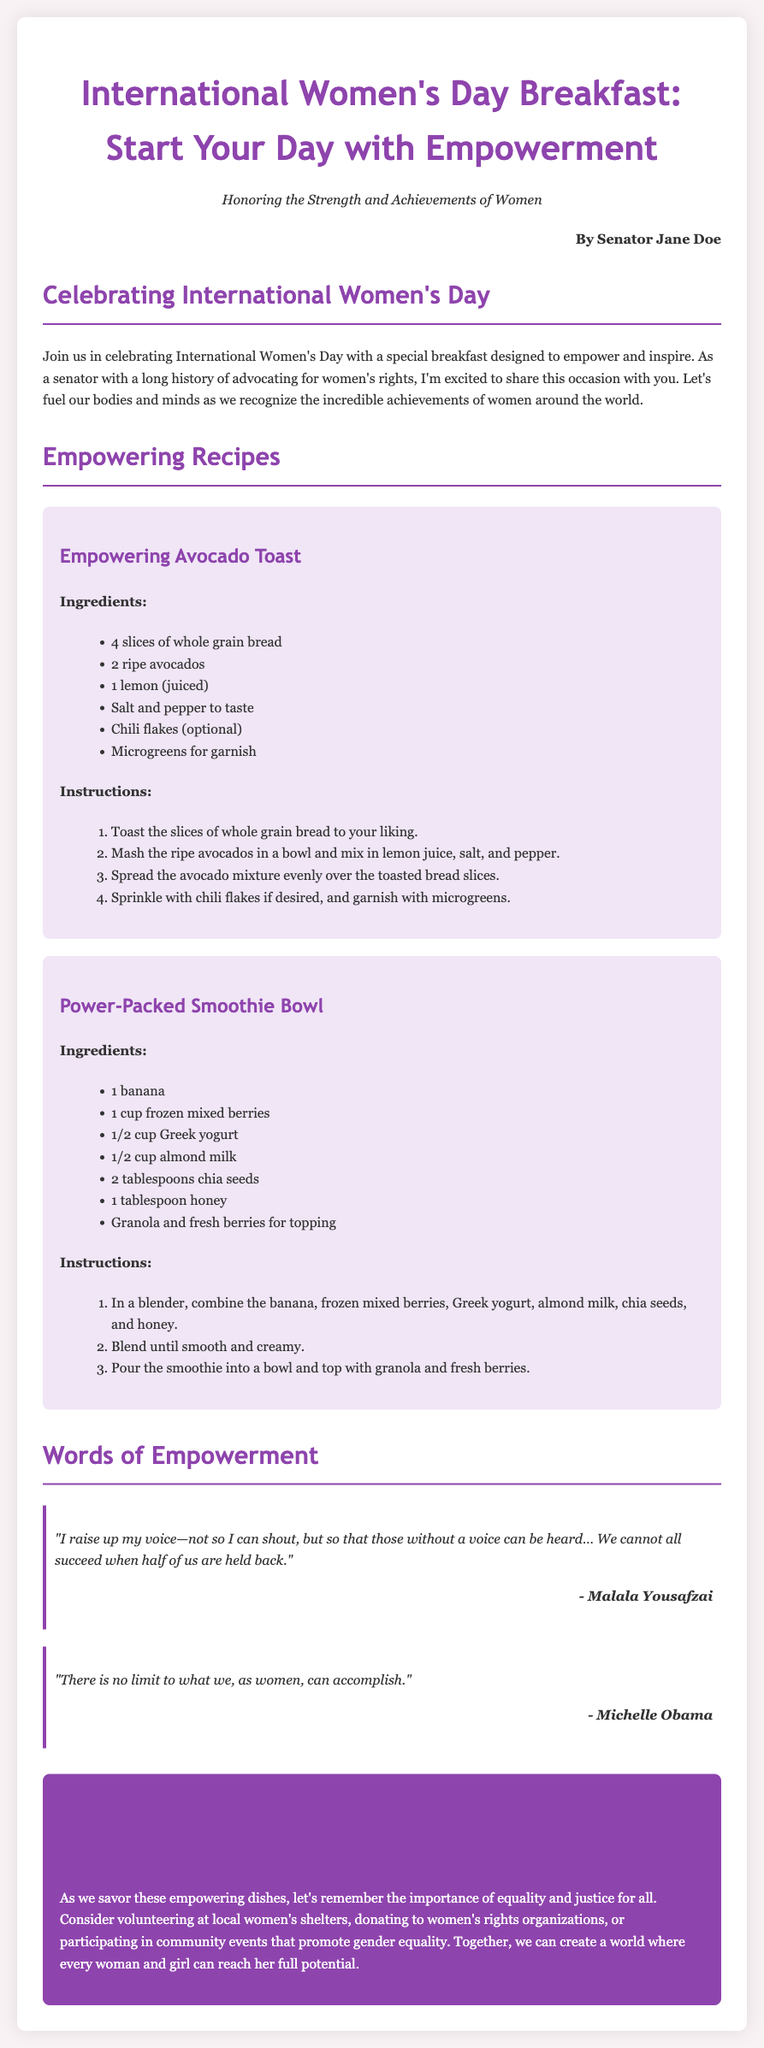What is the title of the document? The title is prominently displayed at the top of the document.
Answer: International Women's Day Breakfast: Start Your Day with Empowerment Who is the author of the document? The author is indicated in the byline below the subtitle.
Answer: Senator Jane Doe What are the main ingredients for the Empowering Avocado Toast? This information can be found in the ingredient list for the recipe.
Answer: 4 slices of whole grain bread, 2 ripe avocados, 1 lemon, salt and pepper to taste How many ingredients are listed for the Power-Packed Smoothie Bowl? The number of items can be counted from the ingredient list provided.
Answer: 7 Which quote is attributed to Malala Yousafzai? The specific quote needs to be referenced from the quote section of the document.
Answer: "I raise up my voice—not so I can shout, but so that those without a voice can be heard… We cannot all succeed when half of us are held back." What action does the document suggest to promote gender equality? This information is found in the "Take Action" section of the document.
Answer: Volunteering at local women's shelters How many recipes are included in the document? The number of recipe sections can be counted in the document.
Answer: 2 What is the background color of the body in the document? The background color is described in the styling of the document.
Answer: #f9f2f4 What is the font used for headings in the document? The font is specified in the CSS part of the document.
Answer: Trebuchet MS 